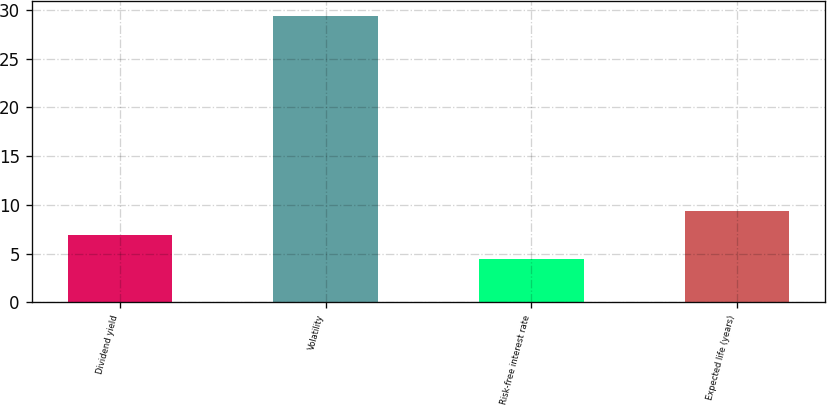Convert chart to OTSL. <chart><loc_0><loc_0><loc_500><loc_500><bar_chart><fcel>Dividend yield<fcel>Volatility<fcel>Risk-free interest rate<fcel>Expected life (years)<nl><fcel>6.9<fcel>29.4<fcel>4.4<fcel>9.4<nl></chart> 